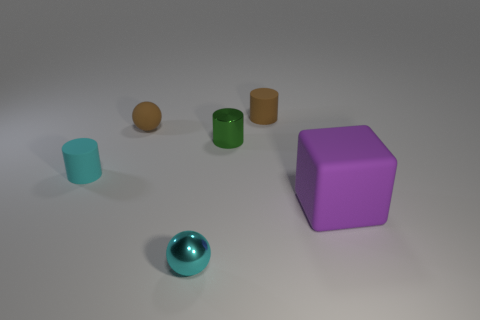Add 2 purple matte things. How many objects exist? 8 Subtract all spheres. How many objects are left? 4 Subtract all tiny brown spheres. Subtract all small cyan cylinders. How many objects are left? 4 Add 6 cylinders. How many cylinders are left? 9 Add 6 tiny green metal objects. How many tiny green metal objects exist? 7 Subtract 1 brown cylinders. How many objects are left? 5 